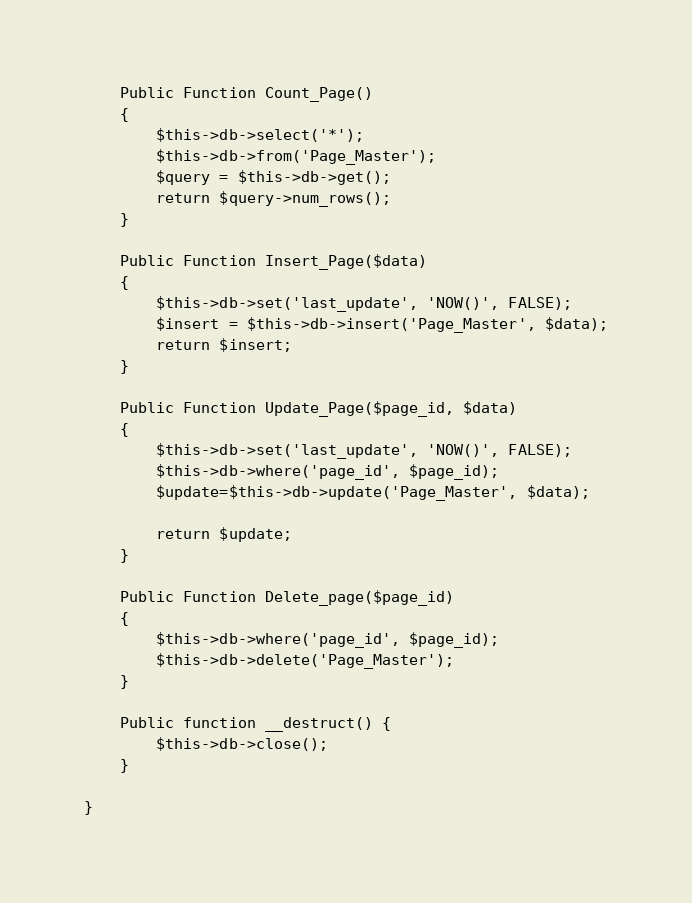Convert code to text. <code><loc_0><loc_0><loc_500><loc_500><_PHP_>    Public Function Count_Page()
    {
        $this->db->select('*');
        $this->db->from('Page_Master');
        $query = $this->db->get();
        return $query->num_rows();  
    }

    Public Function Insert_Page($data)
    {
        $this->db->set('last_update', 'NOW()', FALSE);
        $insert = $this->db->insert('Page_Master', $data);
        return $insert;
    }

    Public Function Update_Page($page_id, $data)
    {
        $this->db->set('last_update', 'NOW()', FALSE);
        $this->db->where('page_id', $page_id);
        $update=$this->db->update('Page_Master', $data);
        
        return $update;
    }

    Public Function Delete_page($page_id)
    {
        $this->db->where('page_id', $page_id);
        $this->db->delete('Page_Master'); 
    }
    
    Public function __destruct() {  
        $this->db->close();  
    }    
        
}

</code> 